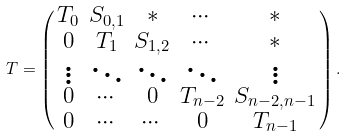<formula> <loc_0><loc_0><loc_500><loc_500>T = \left ( \begin{smallmatrix} T _ { 0 } & S _ { 0 , 1 } & * & \cdots & * \\ 0 & T _ { 1 } & S _ { 1 , 2 } & \cdots & * \\ \vdots & \ddots & \ddots & \ddots & \vdots \\ 0 & \cdots & 0 & T _ { n - 2 } & S _ { n - 2 , n - 1 } \\ 0 & \cdots & \cdots & 0 & T _ { n - 1 } \end{smallmatrix} \right ) .</formula> 